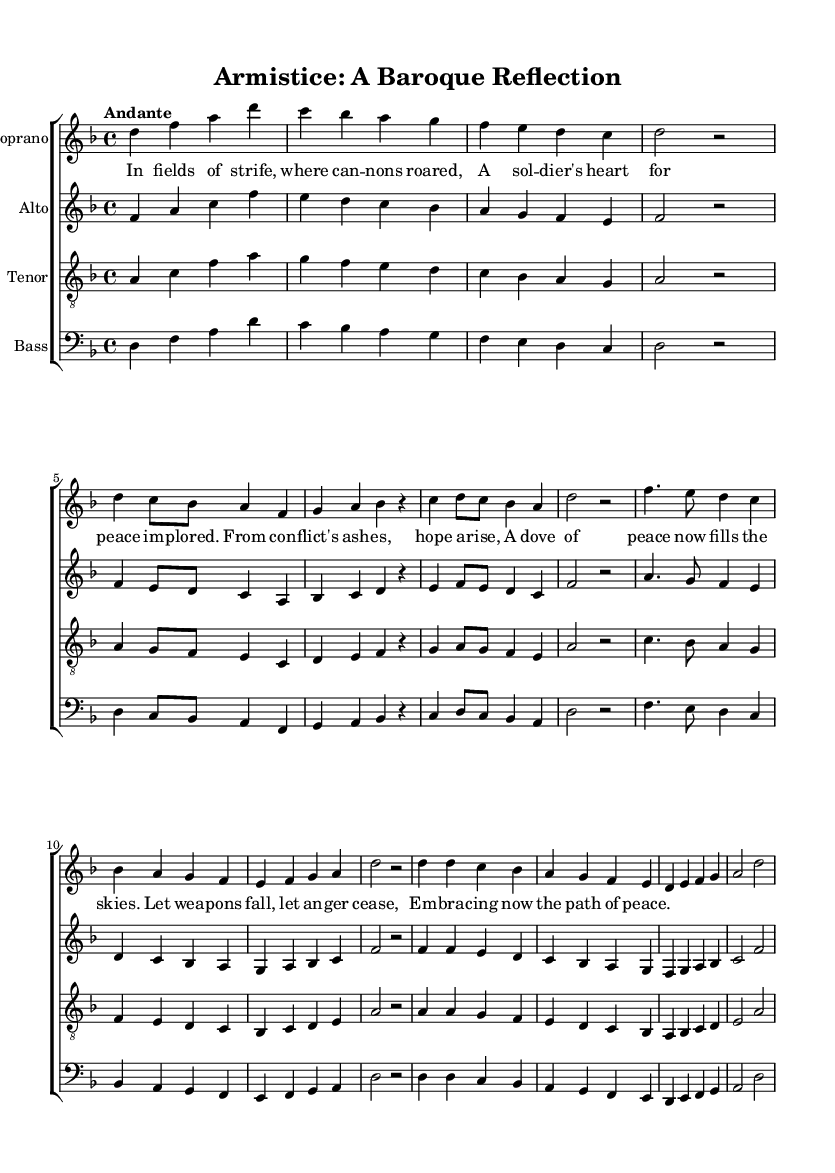What is the key signature of this music? The key signature indicated in the global section specifies D minor, which has one flat (B flat).
Answer: D minor What is the time signature of the piece? The time signature, as indicated at the beginning of the score, is 4/4, meaning there are four beats in each measure.
Answer: 4/4 What tempo marking is specified for this composition? The tempo marking given is "Andante," which indicates a moderately slow tempo, typically at a walking pace.
Answer: Andante How many distinct vocal parts are included in the score? The score includes four distinct vocal parts: soprano, alto, tenor, and bass, as indicated by separate staves for each voice.
Answer: Four What is the opening musical section called? The opening section is termed the "Overture," as indicated in the soprano line and typically introduces the themes of the work.
Answer: Overture What is the primary theme expressed in the lyrics? The lyrics reflect themes of peace arising from conflict and the desire to end fighting, as described in phrases about soldiers and hope.
Answer: Peace Which musical form is predominantly used in this oratorio? The predominant form in this oratorio can be identified as "Aria" for its solo passages and "Chorus" for the ensemble sections that involve all voices.
Answer: Aria and Chorus 